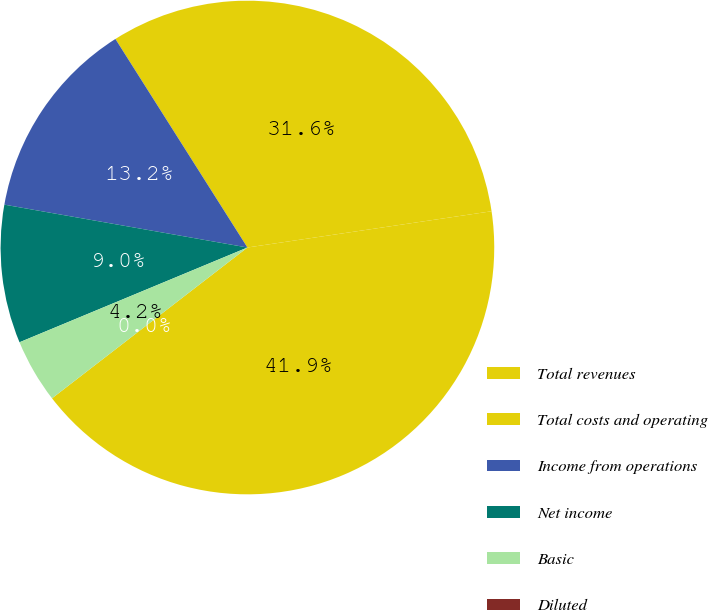Convert chart to OTSL. <chart><loc_0><loc_0><loc_500><loc_500><pie_chart><fcel>Total revenues<fcel>Total costs and operating<fcel>Income from operations<fcel>Net income<fcel>Basic<fcel>Diluted<nl><fcel>41.89%<fcel>31.64%<fcel>13.24%<fcel>9.05%<fcel>4.19%<fcel>0.0%<nl></chart> 